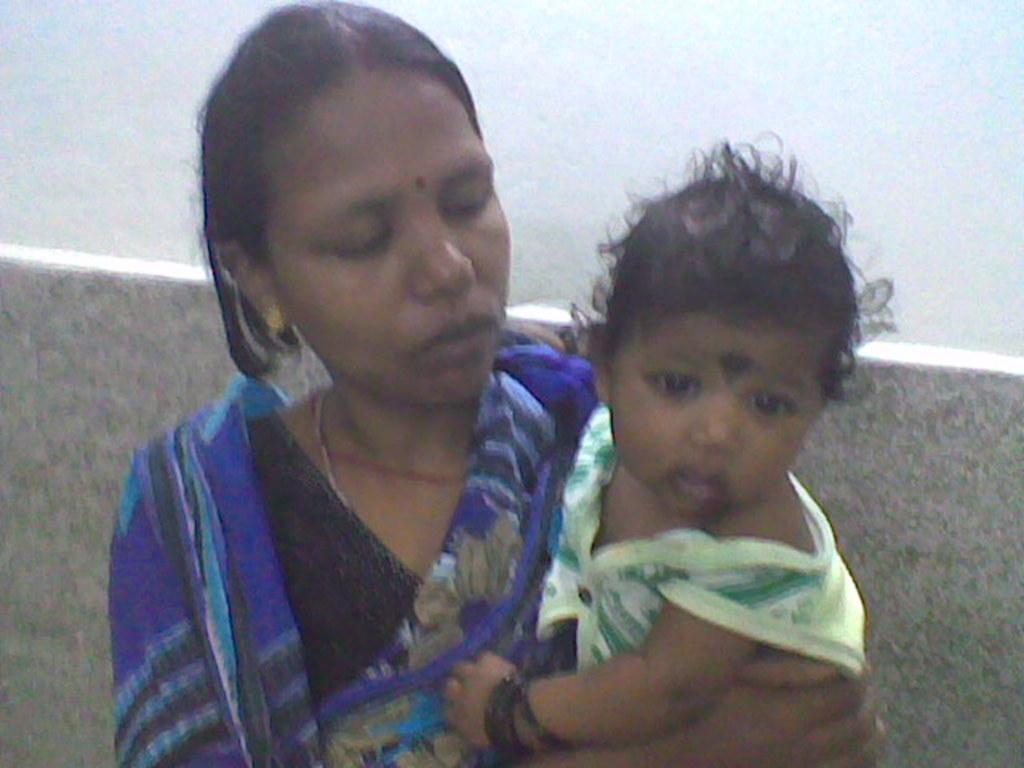Please provide a concise description of this image. In this game we can see a woman holding baby. 